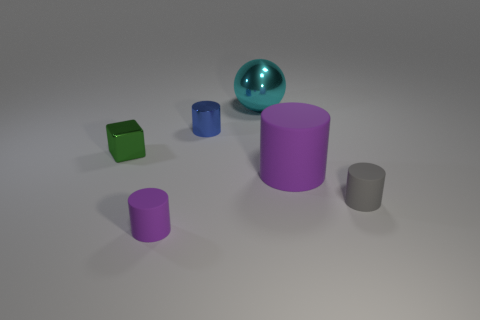What number of other things are there of the same color as the block?
Provide a succinct answer. 0. Is the blue object the same size as the cyan ball?
Your answer should be compact. No. How many objects are either large green shiny spheres or tiny rubber cylinders that are on the right side of the large sphere?
Give a very brief answer. 1. Is the number of cyan metal things on the left side of the cyan metallic ball less than the number of tiny matte things to the left of the small gray cylinder?
Ensure brevity in your answer.  Yes. What number of other objects are there of the same material as the large purple thing?
Offer a terse response. 2. There is a small thing that is right of the sphere; is its color the same as the block?
Give a very brief answer. No. Are there any purple matte cylinders that are behind the small cylinder that is behind the small metallic block?
Provide a short and direct response. No. There is a cylinder that is on the left side of the large cyan ball and in front of the metallic cylinder; what is its material?
Give a very brief answer. Rubber. There is a small green thing that is made of the same material as the large cyan ball; what shape is it?
Provide a succinct answer. Cube. Are there any other things that have the same shape as the blue metal object?
Offer a terse response. Yes. 